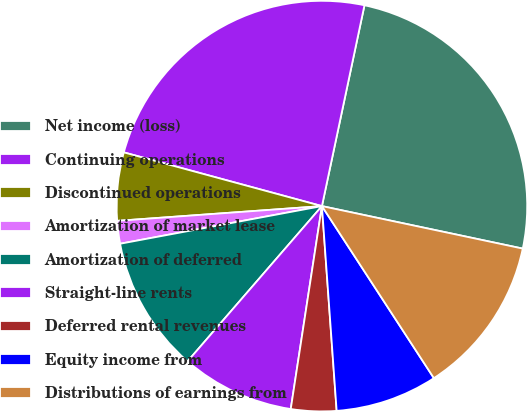<chart> <loc_0><loc_0><loc_500><loc_500><pie_chart><fcel>Net income (loss)<fcel>Continuing operations<fcel>Discontinued operations<fcel>Amortization of market lease<fcel>Amortization of deferred<fcel>Straight-line rents<fcel>Deferred rental revenues<fcel>Equity income from<fcel>Distributions of earnings from<nl><fcel>25.0%<fcel>24.11%<fcel>5.36%<fcel>1.79%<fcel>10.71%<fcel>8.93%<fcel>3.57%<fcel>8.04%<fcel>12.5%<nl></chart> 